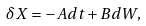Convert formula to latex. <formula><loc_0><loc_0><loc_500><loc_500>\delta X = - A d t + B d W ,</formula> 